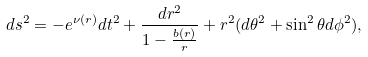<formula> <loc_0><loc_0><loc_500><loc_500>d s ^ { 2 } = - e ^ { \nu ( r ) } d t ^ { 2 } + \frac { d r ^ { 2 } } { 1 - \frac { b ( r ) } { r } } + r ^ { 2 } ( d \theta ^ { 2 } + \sin ^ { 2 } \theta d \phi ^ { 2 } ) ,</formula> 